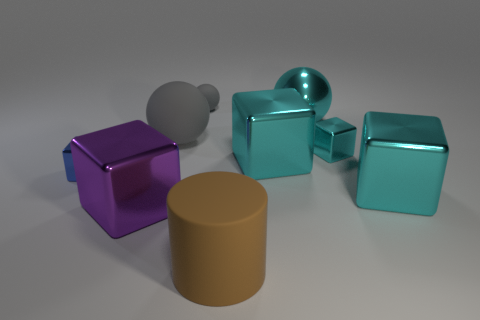What number of big things are either metallic objects or blue metal blocks?
Make the answer very short. 4. There is a blue metal object that is the same shape as the big purple thing; what size is it?
Your response must be concise. Small. The small block right of the big cube that is behind the tiny blue block is made of what material?
Give a very brief answer. Metal. What number of metallic objects are either tiny spheres or small cyan cubes?
Give a very brief answer. 1. The big metallic object that is the same shape as the small matte thing is what color?
Your answer should be very brief. Cyan. How many large metallic spheres have the same color as the tiny rubber ball?
Give a very brief answer. 0. There is a object that is in front of the big purple thing; is there a big gray matte object that is in front of it?
Offer a very short reply. No. What number of large blocks are both in front of the blue block and behind the big purple cube?
Keep it short and to the point. 1. How many small gray spheres are the same material as the large brown cylinder?
Offer a very short reply. 1. What size is the matte sphere behind the big rubber thing behind the big purple thing?
Your answer should be compact. Small. 